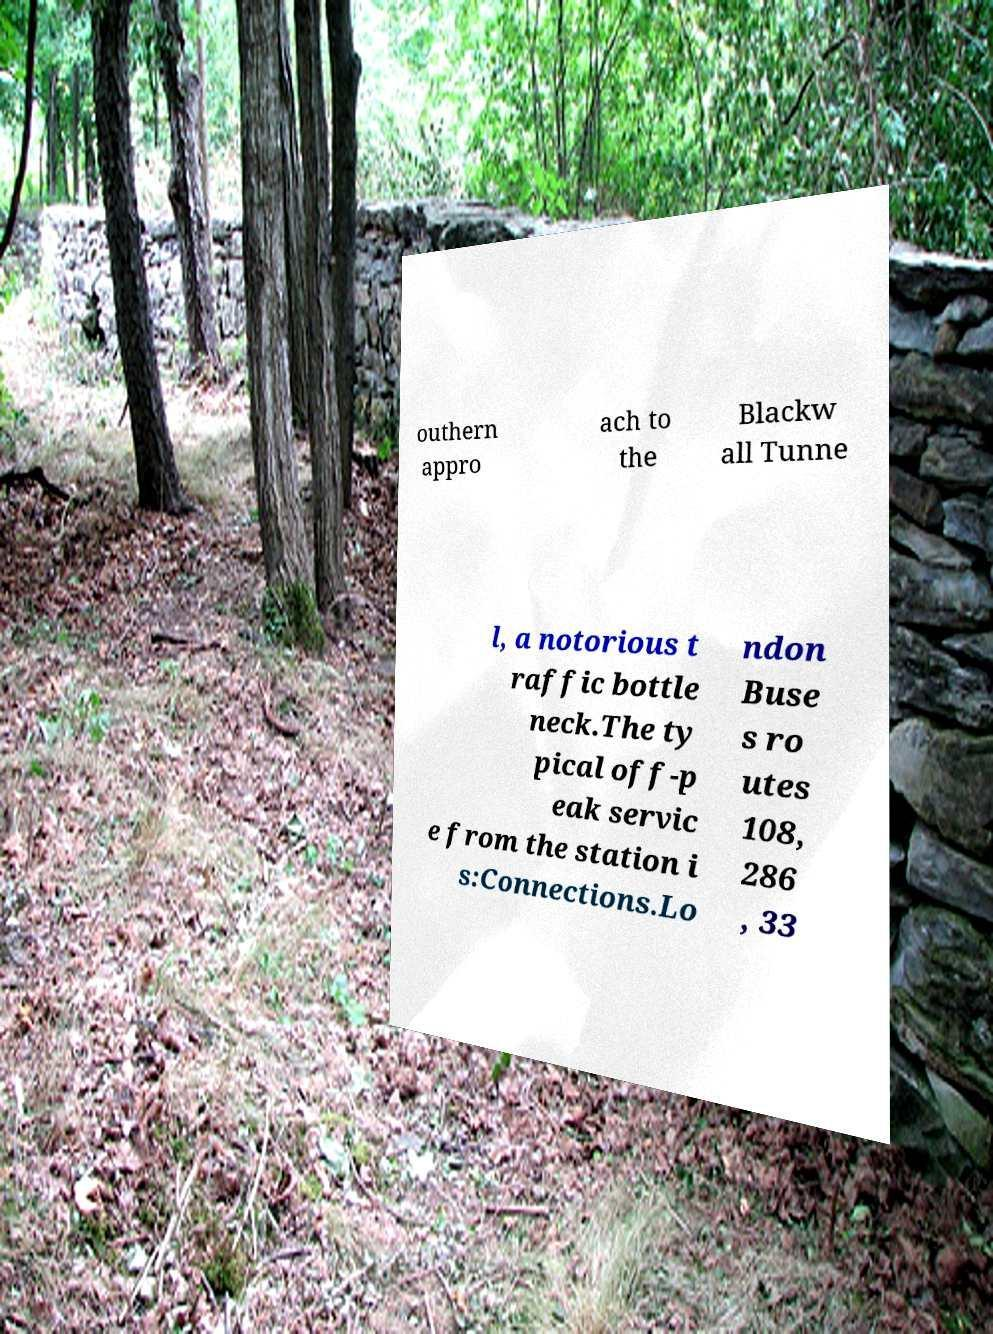Could you extract and type out the text from this image? outhern appro ach to the Blackw all Tunne l, a notorious t raffic bottle neck.The ty pical off-p eak servic e from the station i s:Connections.Lo ndon Buse s ro utes 108, 286 , 33 